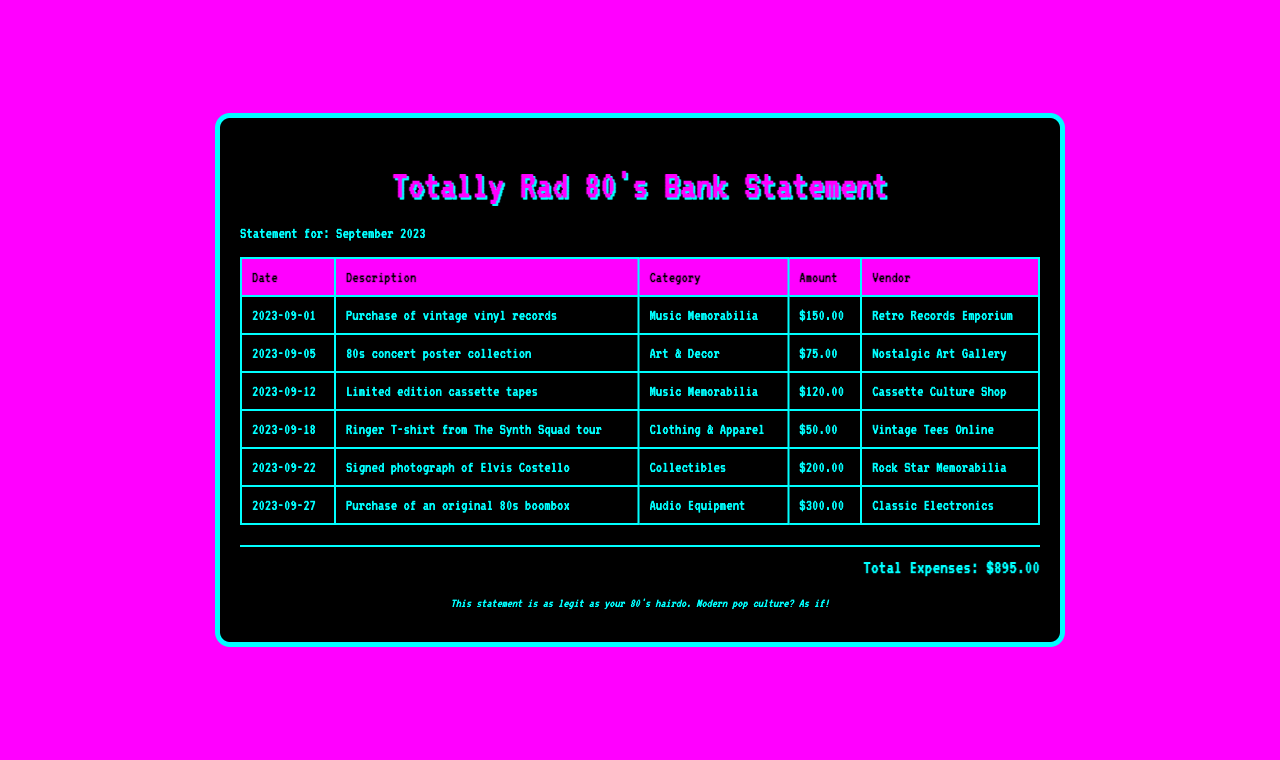What is the total amount spent on music memorabilia? The total amount spent on music memorabilia includes $150.00 and $120.00, totaling $270.00.
Answer: $270.00 Which vendor sold the signed photograph? The signed photograph of Elvis Costello was purchased from Rock Star Memorabilia.
Answer: Rock Star Memorabilia What date was the purchase of the original 80s boombox made? The purchase of the original 80s boombox was made on September 27, 2023.
Answer: 2023-09-27 What is the amount spent on the concert poster collection? The amount spent on the 80s concert poster collection is $75.00.
Answer: $75.00 How many transactions are listed in the bank statement? There are 6 transactions listed in the bank statement.
Answer: 6 Which category does the purchase of vintage vinyl records fall under? The purchase of vintage vinyl records falls under the Music Memorabilia category.
Answer: Music Memorabilia What is the total amount of expenses for September 2023? The total expenses for September 2023 are calculated as the sum of all individual transactions listed in the document, which amounts to $895.00.
Answer: $895.00 Which item was purchased on September 18, 2023? The ringer T-shirt from The Synth Squad tour was purchased on September 18, 2023.
Answer: Ringer T-shirt from The Synth Squad tour What type of collectible was bought for $200.00? The signed photograph of Elvis Costello was bought for $200.00.
Answer: Signed photograph of Elvis Costello 